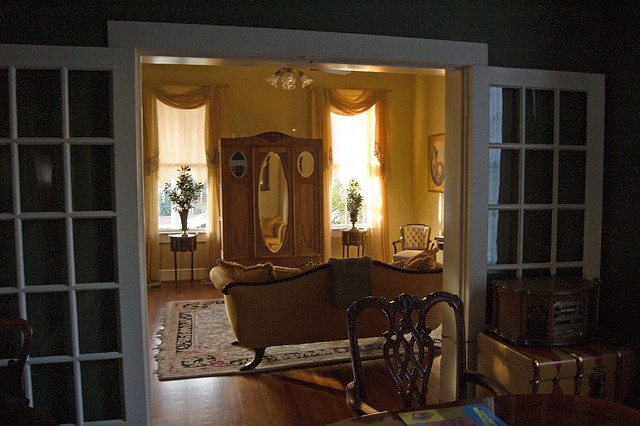Describe the objects in this image and their specific colors. I can see couch in black, maroon, and olive tones, chair in black, maroon, and gray tones, dining table in black, darkgreen, and navy tones, chair in black, gray, and purple tones, and potted plant in black, ivory, darkgreen, and gray tones in this image. 